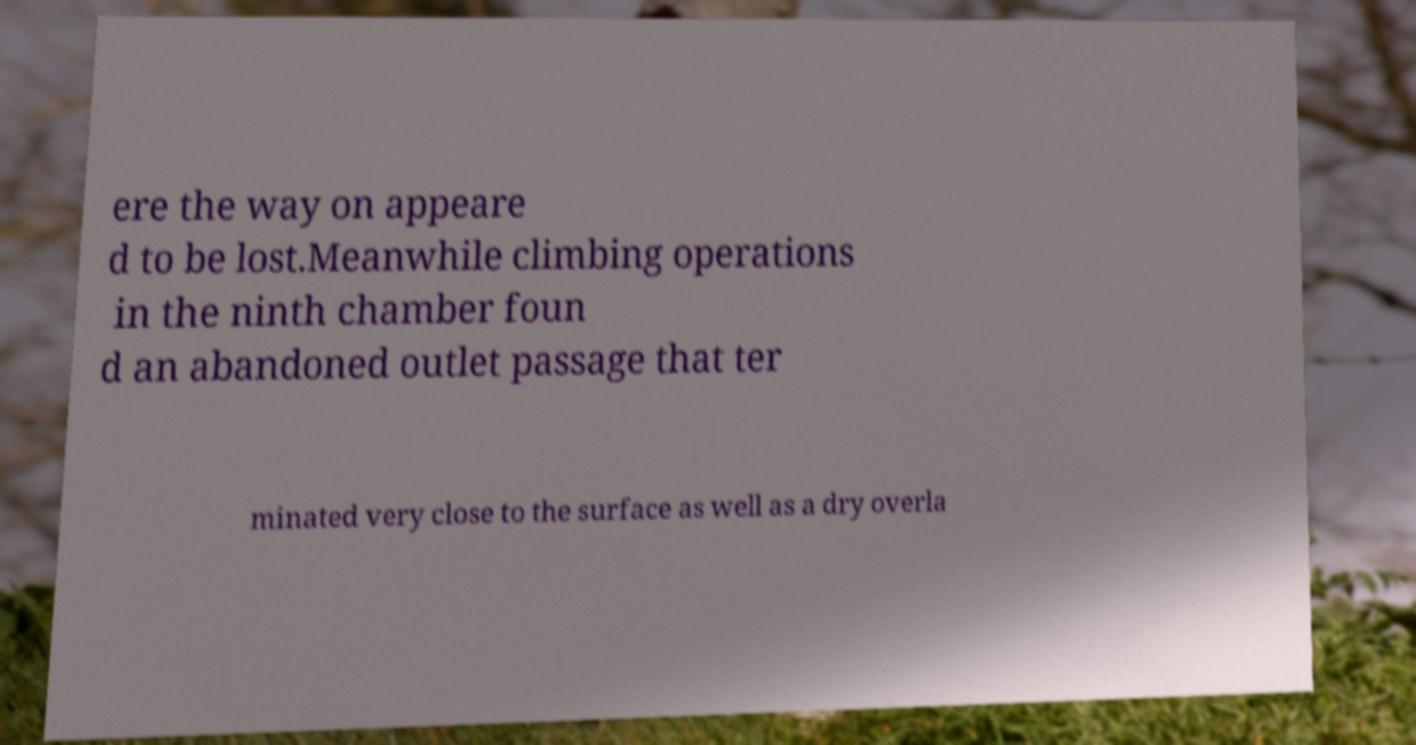For documentation purposes, I need the text within this image transcribed. Could you provide that? ere the way on appeare d to be lost.Meanwhile climbing operations in the ninth chamber foun d an abandoned outlet passage that ter minated very close to the surface as well as a dry overla 